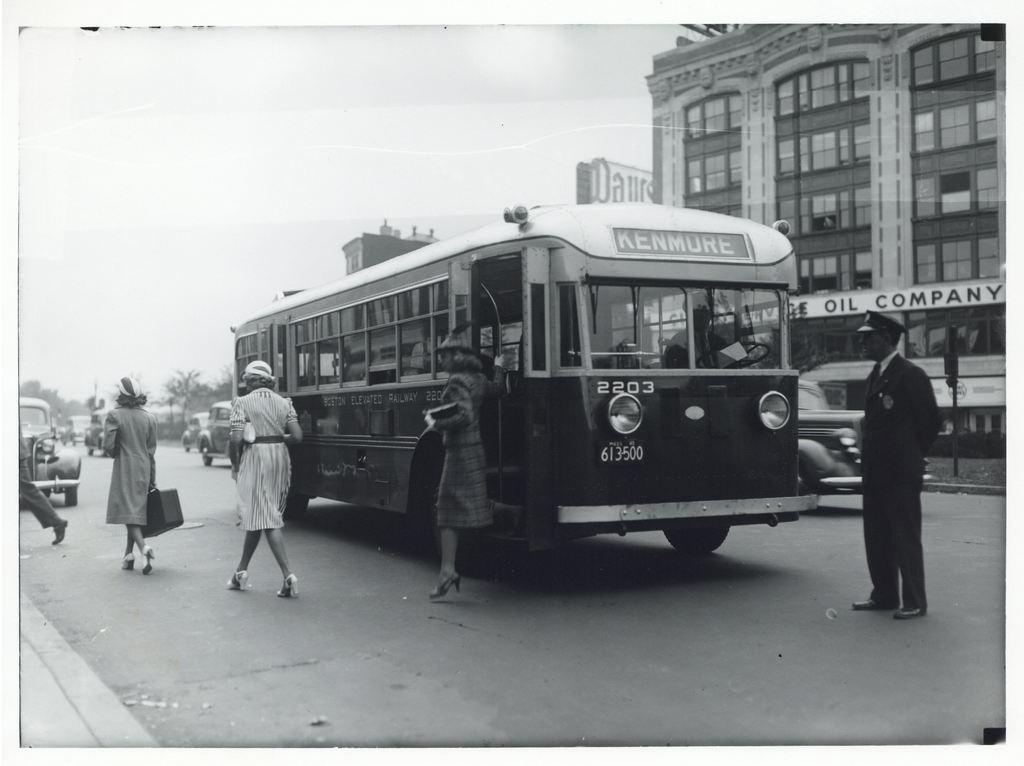How would you summarize this image in a sentence or two? In the image some people are getting down from the bus and behind the bus there is an oil company, there are few other vehicles around the bus and there is a person standing in front of the bus. 